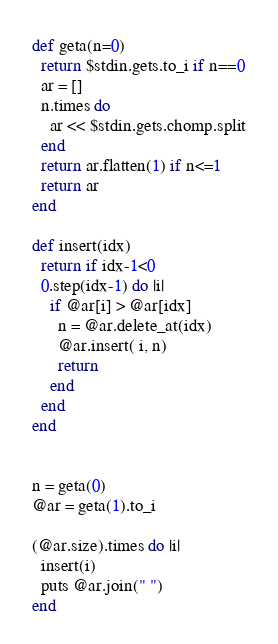Convert code to text. <code><loc_0><loc_0><loc_500><loc_500><_Ruby_>def geta(n=0)
  return $stdin.gets.to_i if n==0
  ar = []
  n.times do 
    ar << $stdin.gets.chomp.split
  end
  return ar.flatten(1) if n<=1
  return ar
end

def insert(idx)
  return if idx-1<0
  0.step(idx-1) do |i|
    if @ar[i] > @ar[idx]
      n = @ar.delete_at(idx)
      @ar.insert( i, n)
      return
    end
  end
end


n = geta(0)
@ar = geta(1).to_i

(@ar.size).times do |i|
  insert(i)
  puts @ar.join(" ")
end
</code> 